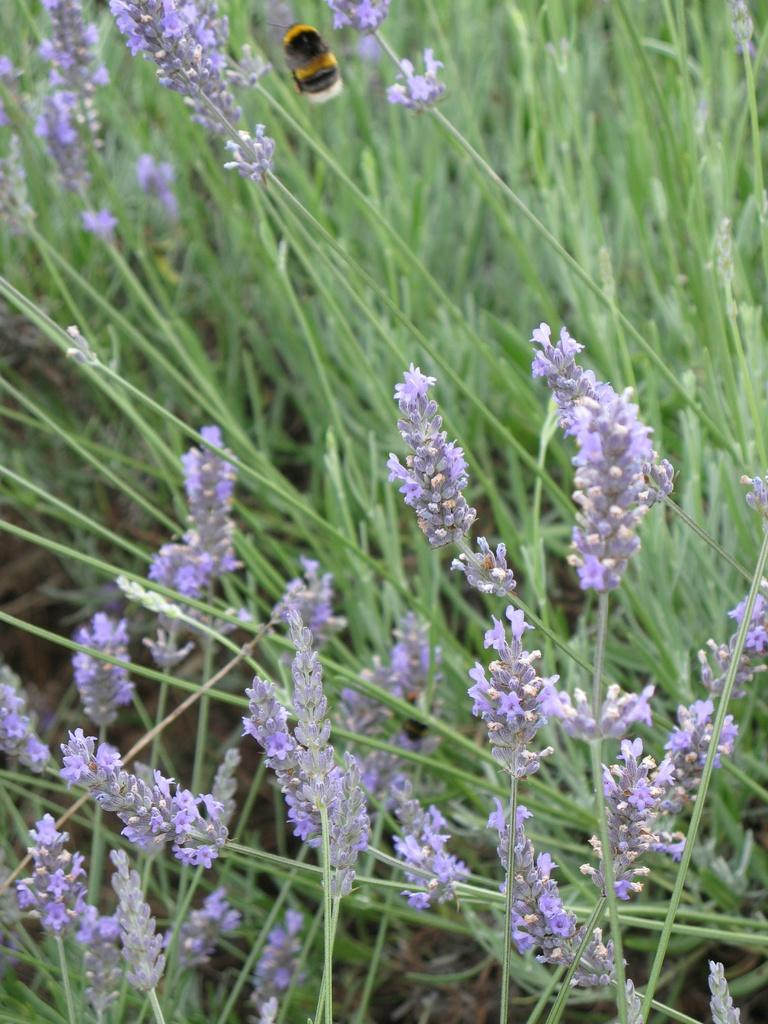What type of living organisms can be seen in the image? Plants and flowers are visible in the image. Can you describe any specific features of the plants? The plants have flowers, which are also visible in the image. What insect can be seen in the image? There is a bee visible at the top of the image. What type of door can be seen in the image? There is no door present in the image; it features plants, flowers, and a bee. How does the cobweb contribute to the growth of the plants in the image? There is no cobweb present in the image, so it cannot contribute to the growth of the plants. 